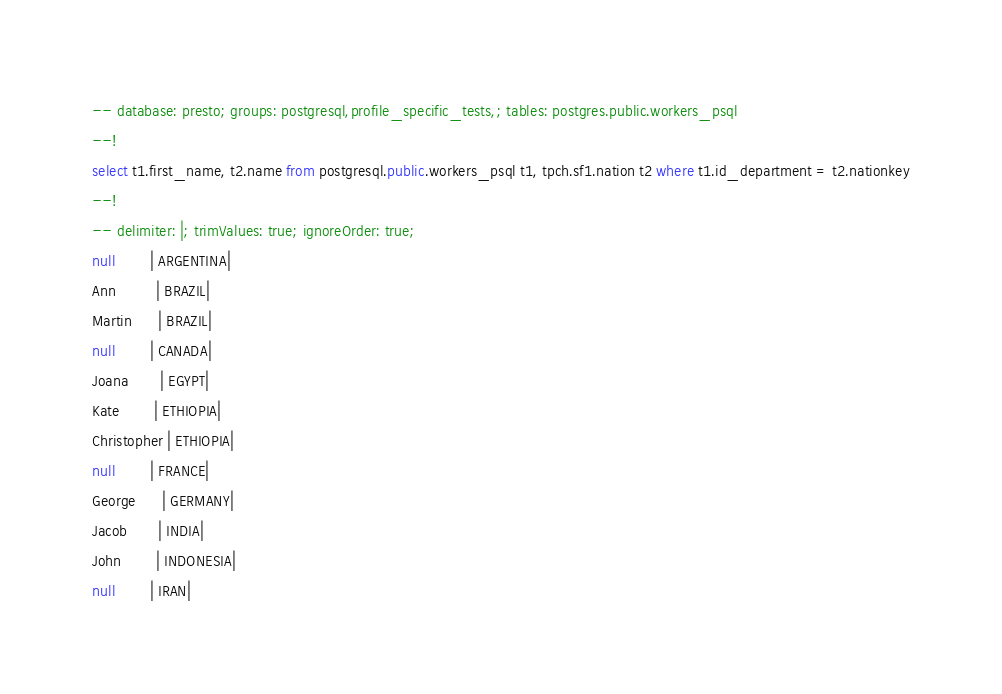<code> <loc_0><loc_0><loc_500><loc_500><_SQL_>-- database: presto; groups: postgresql,profile_specific_tests,; tables: postgres.public.workers_psql
--!
select t1.first_name, t2.name from postgresql.public.workers_psql t1, tpch.sf1.nation t2 where t1.id_department = t2.nationkey
--!
-- delimiter: |; trimValues: true; ignoreOrder: true;
null        | ARGENTINA|
Ann         | BRAZIL|
Martin      | BRAZIL|
null        | CANADA|
Joana       | EGYPT|
Kate        | ETHIOPIA|
Christopher | ETHIOPIA|
null        | FRANCE|
George      | GERMANY|
Jacob       | INDIA|
John        | INDONESIA|
null        | IRAN|
</code> 